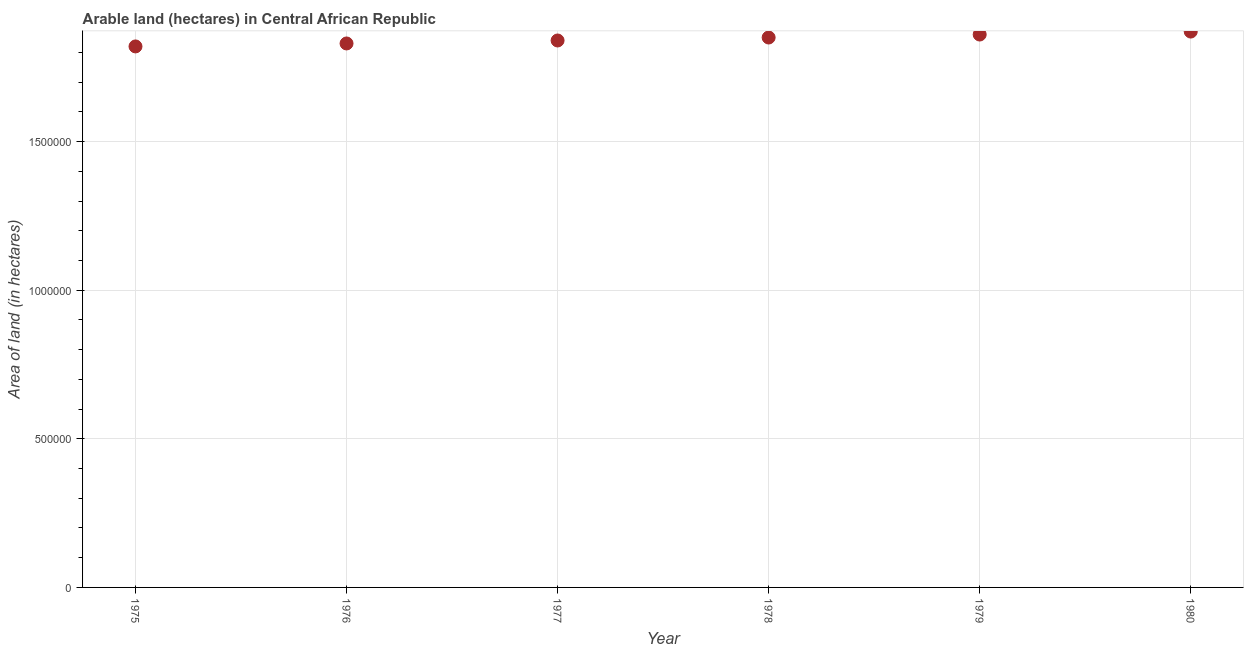What is the area of land in 1979?
Your answer should be compact. 1.86e+06. Across all years, what is the maximum area of land?
Provide a succinct answer. 1.87e+06. Across all years, what is the minimum area of land?
Provide a short and direct response. 1.82e+06. In which year was the area of land maximum?
Make the answer very short. 1980. In which year was the area of land minimum?
Provide a short and direct response. 1975. What is the sum of the area of land?
Provide a short and direct response. 1.11e+07. What is the difference between the area of land in 1975 and 1979?
Ensure brevity in your answer.  -4.00e+04. What is the average area of land per year?
Provide a short and direct response. 1.84e+06. What is the median area of land?
Your answer should be very brief. 1.84e+06. In how many years, is the area of land greater than 800000 hectares?
Ensure brevity in your answer.  6. Do a majority of the years between 1975 and 1979 (inclusive) have area of land greater than 400000 hectares?
Make the answer very short. Yes. What is the ratio of the area of land in 1975 to that in 1980?
Your response must be concise. 0.97. What is the difference between the highest and the lowest area of land?
Offer a terse response. 5.00e+04. In how many years, is the area of land greater than the average area of land taken over all years?
Keep it short and to the point. 3. How many dotlines are there?
Give a very brief answer. 1. Does the graph contain any zero values?
Your answer should be compact. No. What is the title of the graph?
Your answer should be compact. Arable land (hectares) in Central African Republic. What is the label or title of the Y-axis?
Provide a short and direct response. Area of land (in hectares). What is the Area of land (in hectares) in 1975?
Offer a very short reply. 1.82e+06. What is the Area of land (in hectares) in 1976?
Offer a terse response. 1.83e+06. What is the Area of land (in hectares) in 1977?
Your response must be concise. 1.84e+06. What is the Area of land (in hectares) in 1978?
Offer a very short reply. 1.85e+06. What is the Area of land (in hectares) in 1979?
Ensure brevity in your answer.  1.86e+06. What is the Area of land (in hectares) in 1980?
Keep it short and to the point. 1.87e+06. What is the difference between the Area of land (in hectares) in 1975 and 1976?
Make the answer very short. -10000. What is the difference between the Area of land (in hectares) in 1975 and 1977?
Give a very brief answer. -2.00e+04. What is the difference between the Area of land (in hectares) in 1975 and 1979?
Give a very brief answer. -4.00e+04. What is the difference between the Area of land (in hectares) in 1975 and 1980?
Make the answer very short. -5.00e+04. What is the difference between the Area of land (in hectares) in 1976 and 1980?
Give a very brief answer. -4.00e+04. What is the difference between the Area of land (in hectares) in 1977 and 1980?
Give a very brief answer. -3.00e+04. What is the ratio of the Area of land (in hectares) in 1975 to that in 1977?
Your answer should be very brief. 0.99. What is the ratio of the Area of land (in hectares) in 1975 to that in 1980?
Offer a terse response. 0.97. What is the ratio of the Area of land (in hectares) in 1976 to that in 1979?
Make the answer very short. 0.98. What is the ratio of the Area of land (in hectares) in 1977 to that in 1980?
Make the answer very short. 0.98. What is the ratio of the Area of land (in hectares) in 1978 to that in 1979?
Ensure brevity in your answer.  0.99. What is the ratio of the Area of land (in hectares) in 1978 to that in 1980?
Make the answer very short. 0.99. 